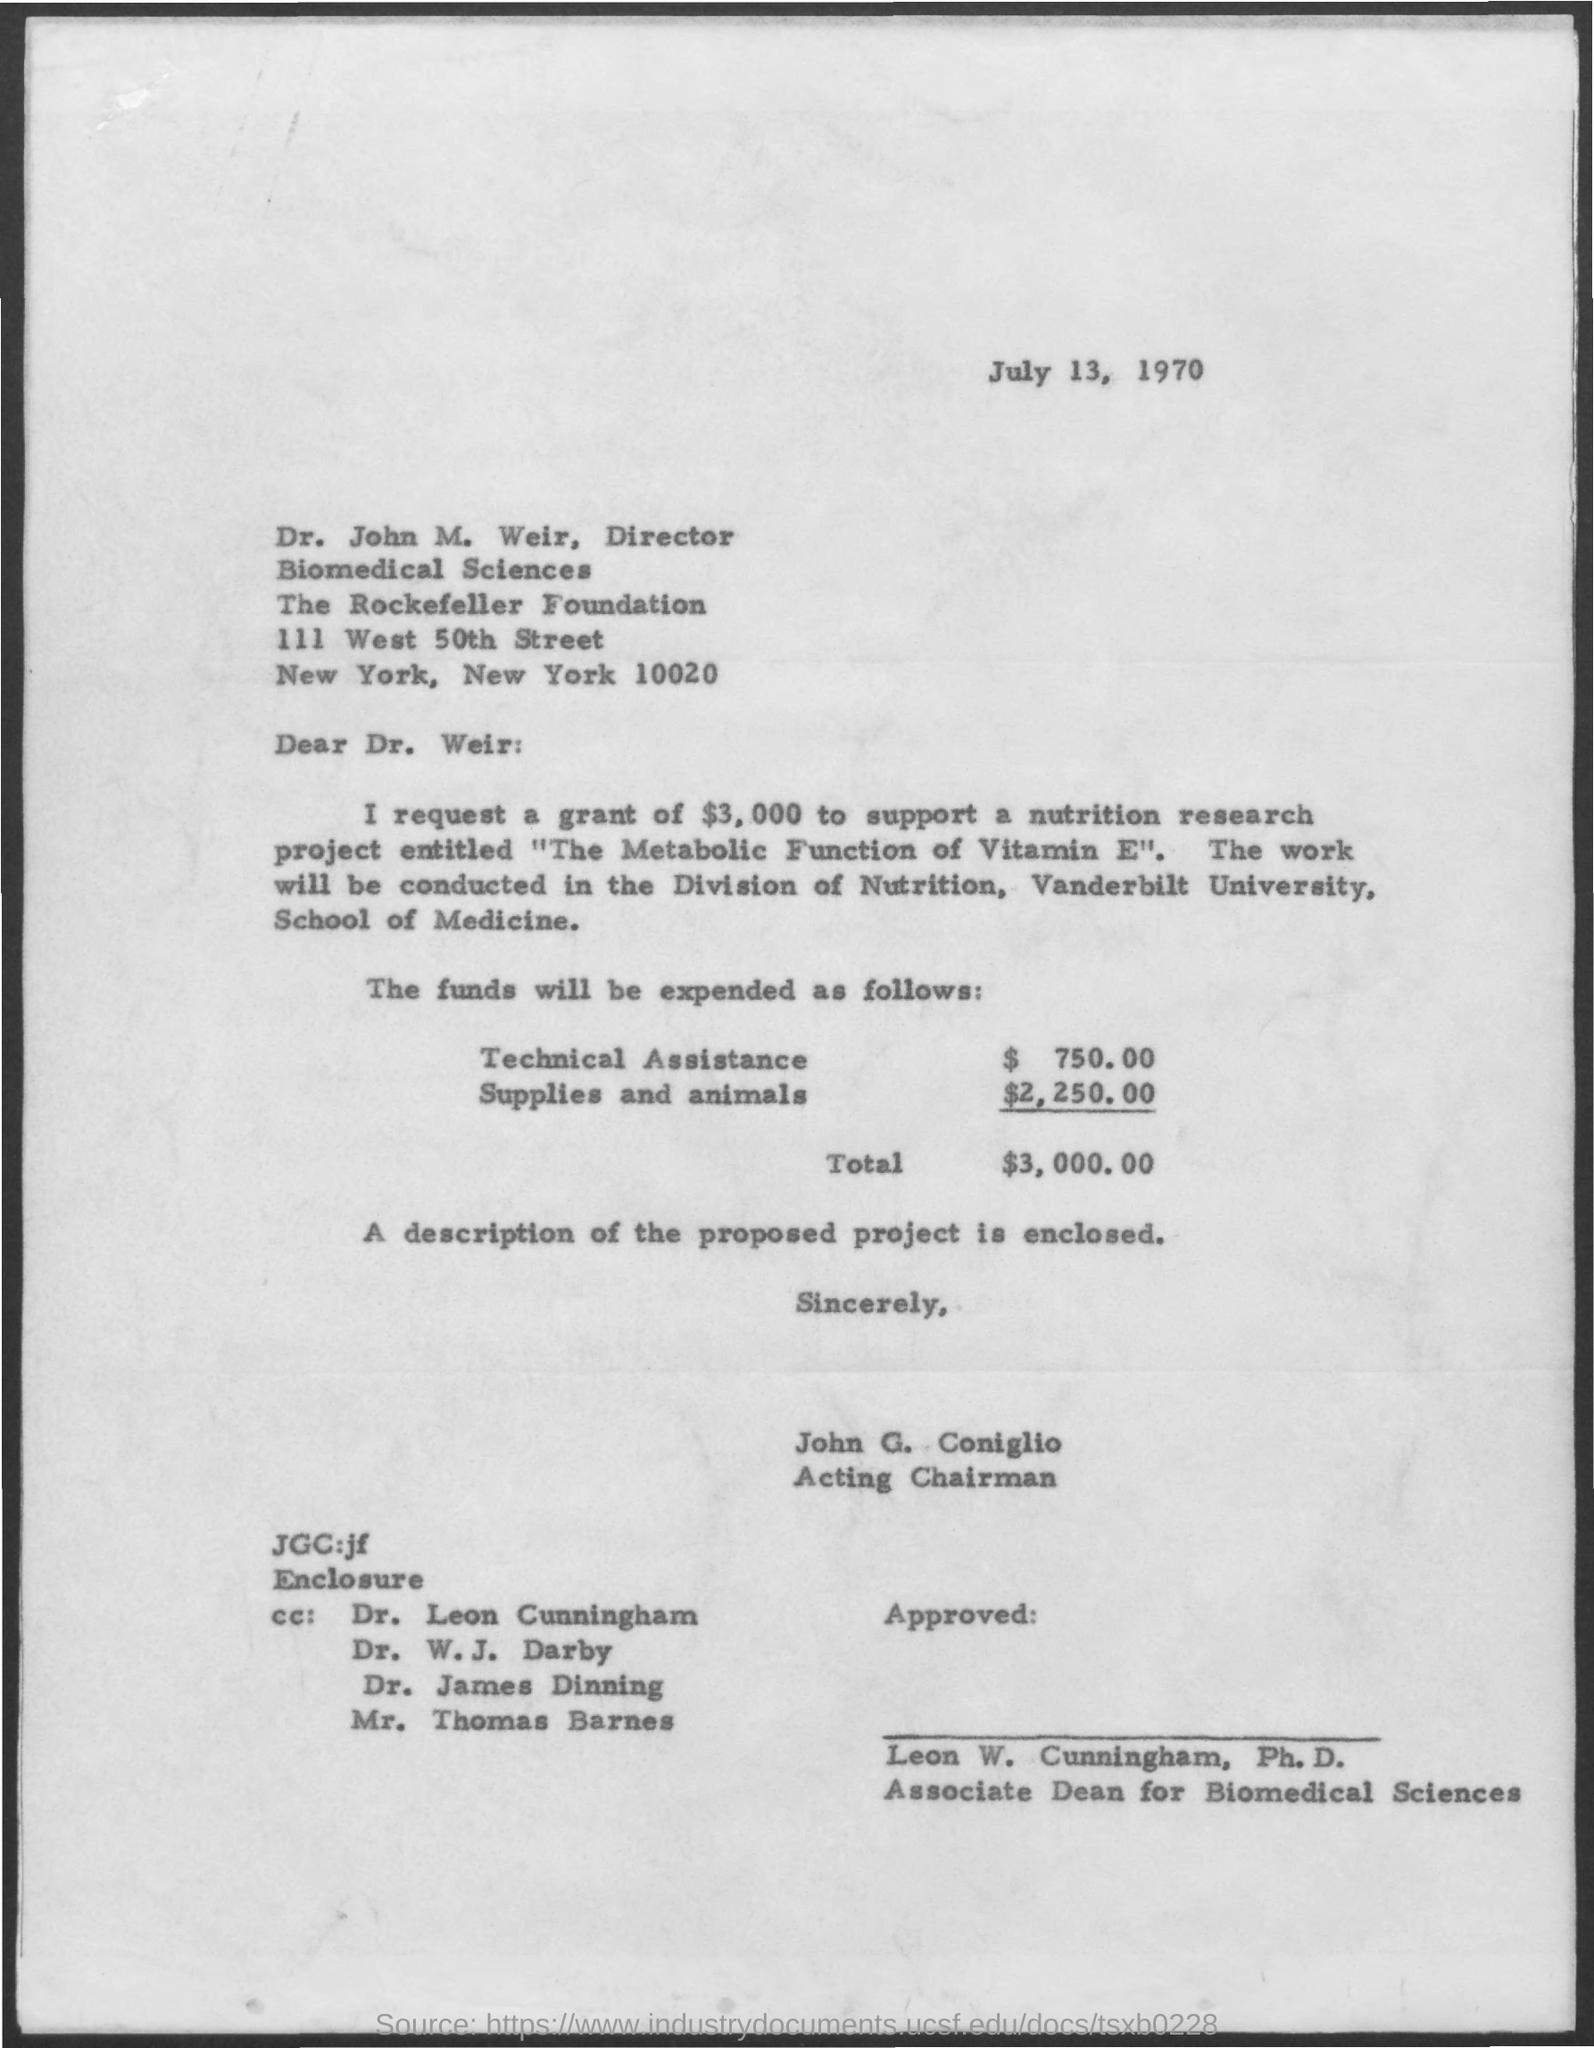Mention a couple of crucial points in this snapshot. The amount mentioned for technical assistance is 750.00. The date mentioned in the given page is July 13, 1970. Dr. John M. Weir's designation is Director. The total amount mentioned in the given form is $3,000.00. The amount mentioned for supplies and animals is $2,250.00. 